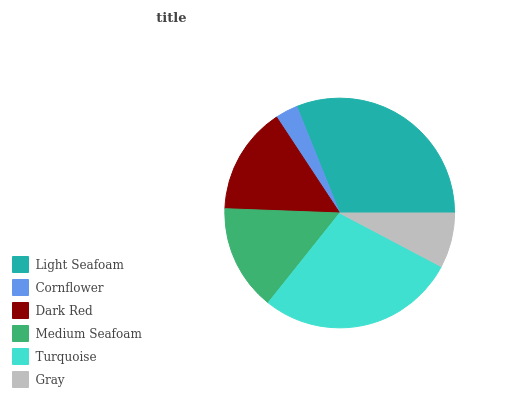Is Cornflower the minimum?
Answer yes or no. Yes. Is Light Seafoam the maximum?
Answer yes or no. Yes. Is Dark Red the minimum?
Answer yes or no. No. Is Dark Red the maximum?
Answer yes or no. No. Is Dark Red greater than Cornflower?
Answer yes or no. Yes. Is Cornflower less than Dark Red?
Answer yes or no. Yes. Is Cornflower greater than Dark Red?
Answer yes or no. No. Is Dark Red less than Cornflower?
Answer yes or no. No. Is Dark Red the high median?
Answer yes or no. Yes. Is Medium Seafoam the low median?
Answer yes or no. Yes. Is Turquoise the high median?
Answer yes or no. No. Is Light Seafoam the low median?
Answer yes or no. No. 